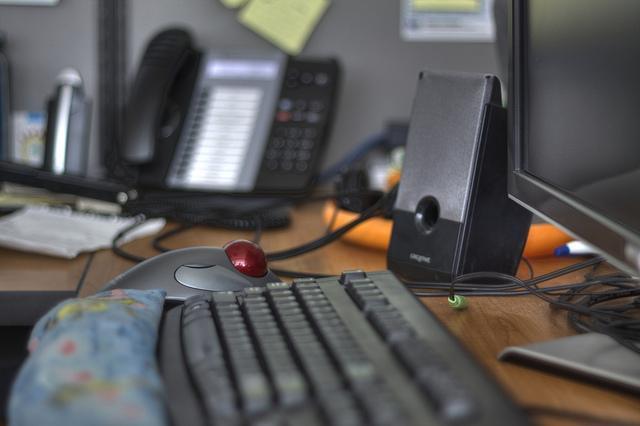How many keyboards are in the photo?
Give a very brief answer. 2. 